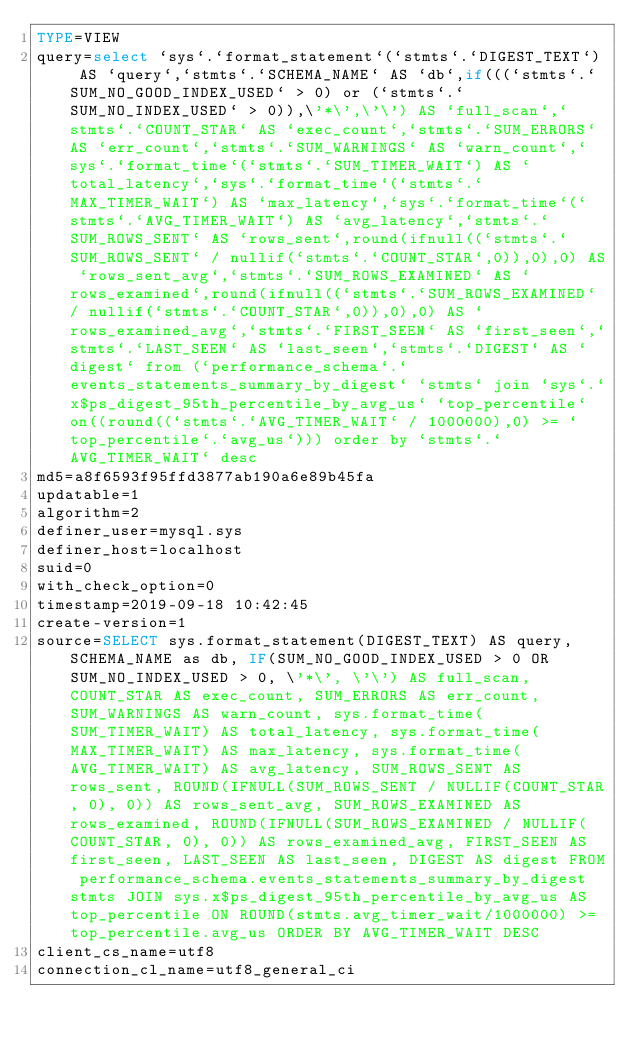Convert code to text. <code><loc_0><loc_0><loc_500><loc_500><_VisualBasic_>TYPE=VIEW
query=select `sys`.`format_statement`(`stmts`.`DIGEST_TEXT`) AS `query`,`stmts`.`SCHEMA_NAME` AS `db`,if(((`stmts`.`SUM_NO_GOOD_INDEX_USED` > 0) or (`stmts`.`SUM_NO_INDEX_USED` > 0)),\'*\',\'\') AS `full_scan`,`stmts`.`COUNT_STAR` AS `exec_count`,`stmts`.`SUM_ERRORS` AS `err_count`,`stmts`.`SUM_WARNINGS` AS `warn_count`,`sys`.`format_time`(`stmts`.`SUM_TIMER_WAIT`) AS `total_latency`,`sys`.`format_time`(`stmts`.`MAX_TIMER_WAIT`) AS `max_latency`,`sys`.`format_time`(`stmts`.`AVG_TIMER_WAIT`) AS `avg_latency`,`stmts`.`SUM_ROWS_SENT` AS `rows_sent`,round(ifnull((`stmts`.`SUM_ROWS_SENT` / nullif(`stmts`.`COUNT_STAR`,0)),0),0) AS `rows_sent_avg`,`stmts`.`SUM_ROWS_EXAMINED` AS `rows_examined`,round(ifnull((`stmts`.`SUM_ROWS_EXAMINED` / nullif(`stmts`.`COUNT_STAR`,0)),0),0) AS `rows_examined_avg`,`stmts`.`FIRST_SEEN` AS `first_seen`,`stmts`.`LAST_SEEN` AS `last_seen`,`stmts`.`DIGEST` AS `digest` from (`performance_schema`.`events_statements_summary_by_digest` `stmts` join `sys`.`x$ps_digest_95th_percentile_by_avg_us` `top_percentile` on((round((`stmts`.`AVG_TIMER_WAIT` / 1000000),0) >= `top_percentile`.`avg_us`))) order by `stmts`.`AVG_TIMER_WAIT` desc
md5=a8f6593f95ffd3877ab190a6e89b45fa
updatable=1
algorithm=2
definer_user=mysql.sys
definer_host=localhost
suid=0
with_check_option=0
timestamp=2019-09-18 10:42:45
create-version=1
source=SELECT sys.format_statement(DIGEST_TEXT) AS query, SCHEMA_NAME as db, IF(SUM_NO_GOOD_INDEX_USED > 0 OR SUM_NO_INDEX_USED > 0, \'*\', \'\') AS full_scan, COUNT_STAR AS exec_count, SUM_ERRORS AS err_count, SUM_WARNINGS AS warn_count, sys.format_time(SUM_TIMER_WAIT) AS total_latency, sys.format_time(MAX_TIMER_WAIT) AS max_latency, sys.format_time(AVG_TIMER_WAIT) AS avg_latency, SUM_ROWS_SENT AS rows_sent, ROUND(IFNULL(SUM_ROWS_SENT / NULLIF(COUNT_STAR, 0), 0)) AS rows_sent_avg, SUM_ROWS_EXAMINED AS rows_examined, ROUND(IFNULL(SUM_ROWS_EXAMINED / NULLIF(COUNT_STAR, 0), 0)) AS rows_examined_avg, FIRST_SEEN AS first_seen, LAST_SEEN AS last_seen, DIGEST AS digest FROM performance_schema.events_statements_summary_by_digest stmts JOIN sys.x$ps_digest_95th_percentile_by_avg_us AS top_percentile ON ROUND(stmts.avg_timer_wait/1000000) >= top_percentile.avg_us ORDER BY AVG_TIMER_WAIT DESC
client_cs_name=utf8
connection_cl_name=utf8_general_ci</code> 